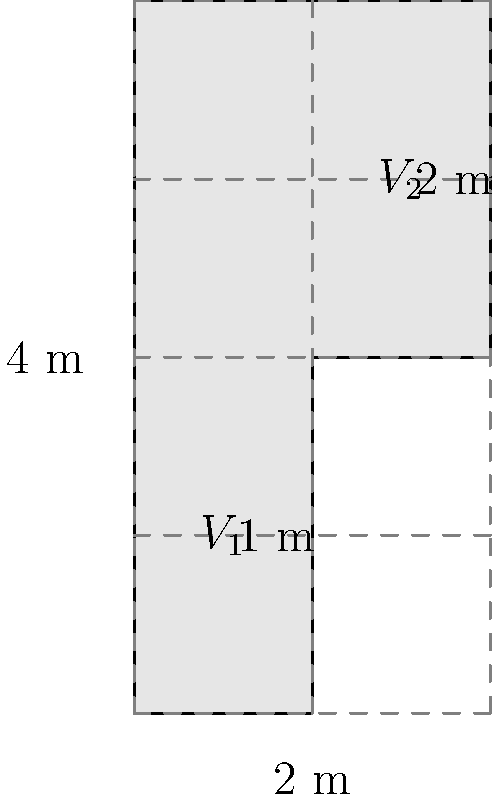As a seasoned entrepreneur, you're considering investing in a unique Lithuanian liquor company. They use an irregularly shaped container for aging their special brew. The container's cross-section is shown in the diagram. If the container has a uniform depth of 3 meters, what is its total volume in cubic meters? Let's approach this step-by-step:

1) We can divide the container into two rectangular sections: $V_1$ and $V_2$.

2) For $V_1$:
   - Width = 1 m
   - Height = 2 m
   - Depth = 3 m (given)
   - Volume of $V_1 = 1 \times 2 \times 3 = 6$ m³

3) For $V_2$:
   - Width = 1 m
   - Height = 2 m
   - Depth = 3 m (given)
   - Volume of $V_2 = 1 \times 2 \times 3 = 6$ m³

4) Total volume = $V_1 + V_2$
                = $6 + 6 = 12$ m³

Therefore, the total volume of the container is 12 cubic meters.
Answer: 12 m³ 